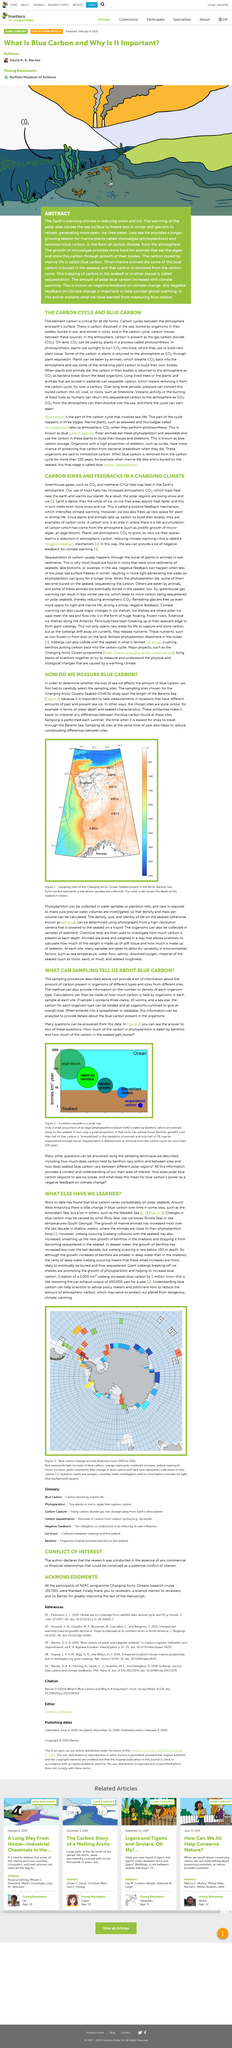Draw attention to some important aspects in this diagram. Blue carbon measurements are taken in the Arctic Barents Sea, where they are used to study the carbon-absorbing qualities of ocean vegetation. The above picture depicts a carbon cascade in a polar sea, which is a visual representation of the complex and dynamic interactions between organic matter and the marine environment. The intricate patterns and colors in the image showcase the various stages of organic matter decay, oxidation, and sedimentation, ultimately resulting in the formation of a carbon-rich sediment that accumulates at the sea floor. The picture serves as a vivid illustration of the importance of carbon cycling in the marine ecosystem, highlighting the crucial role that organic matter plays in shaping the marine environment. Figure 3 displays the changes in blue carbon in Antarctica from 1995 to 2015, as shown in the figure. Changes in blue carbon can be caused by wind, sea ice losses, and increases in sea temperatures. Understanding blue carbon can aid scientists by enabling them to provide policymakers and politicians with informed advice on reducing atmospheric carbon levels. 